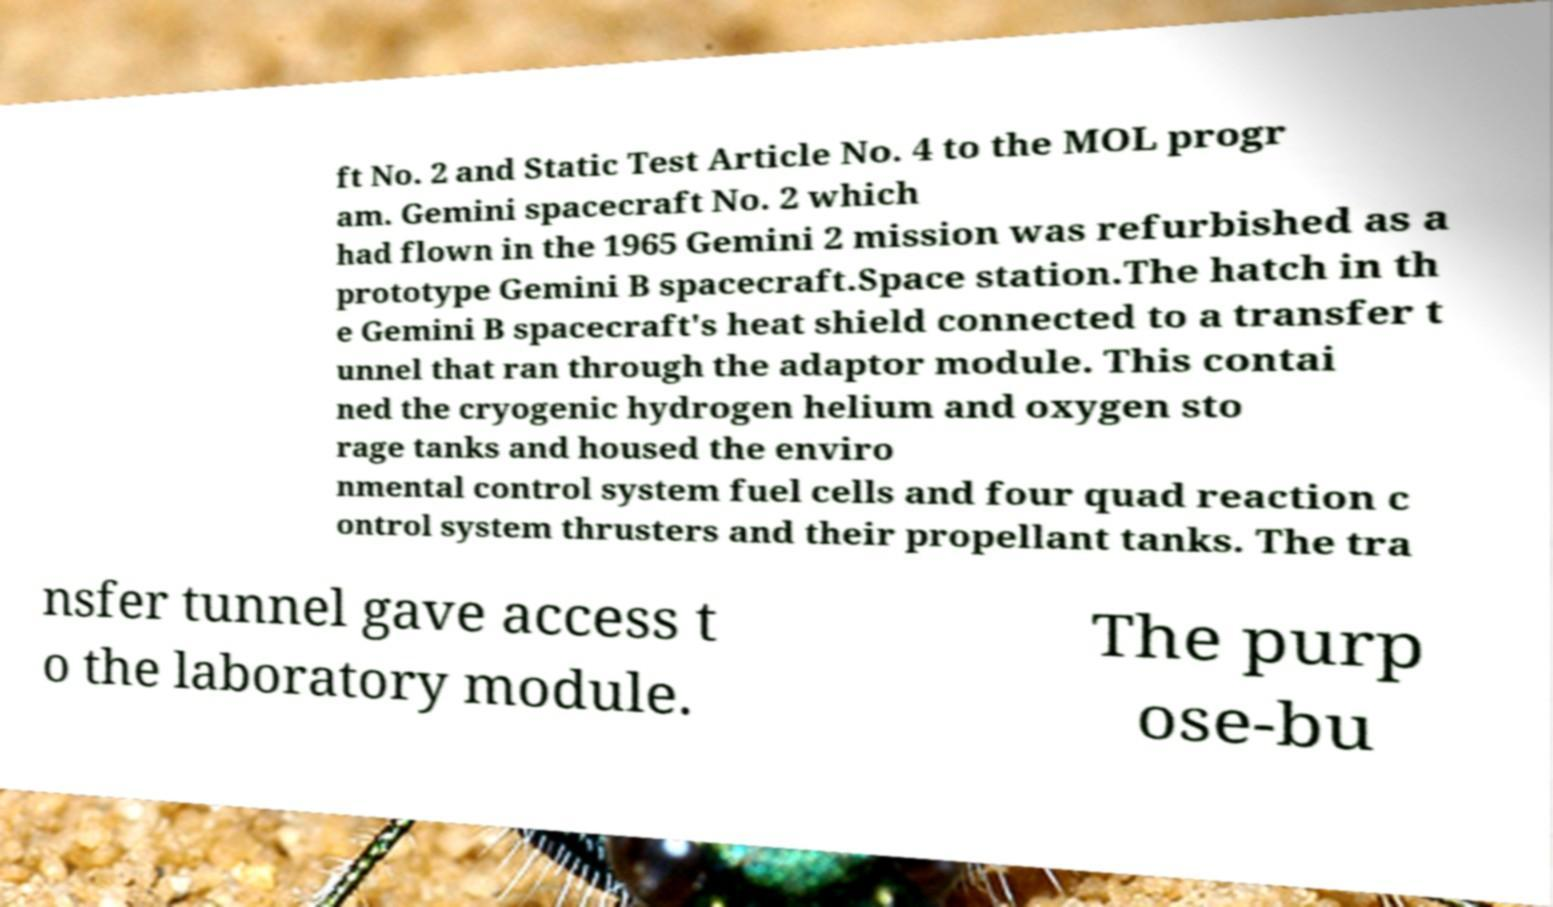Can you read and provide the text displayed in the image?This photo seems to have some interesting text. Can you extract and type it out for me? ft No. 2 and Static Test Article No. 4 to the MOL progr am. Gemini spacecraft No. 2 which had flown in the 1965 Gemini 2 mission was refurbished as a prototype Gemini B spacecraft.Space station.The hatch in th e Gemini B spacecraft's heat shield connected to a transfer t unnel that ran through the adaptor module. This contai ned the cryogenic hydrogen helium and oxygen sto rage tanks and housed the enviro nmental control system fuel cells and four quad reaction c ontrol system thrusters and their propellant tanks. The tra nsfer tunnel gave access t o the laboratory module. The purp ose-bu 